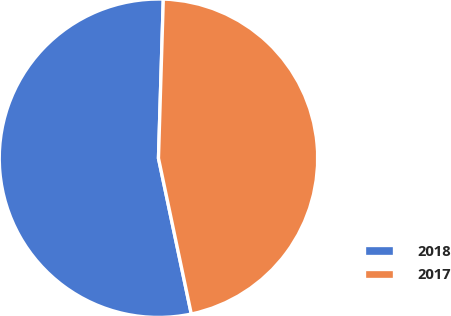<chart> <loc_0><loc_0><loc_500><loc_500><pie_chart><fcel>2018<fcel>2017<nl><fcel>53.79%<fcel>46.21%<nl></chart> 